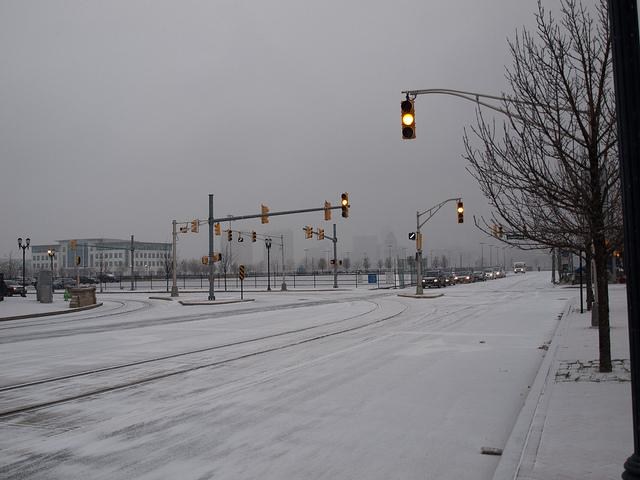Why has caused traffic to be so light on this roadway? Please explain your reasoning. snow. The snow caused the lightness. 